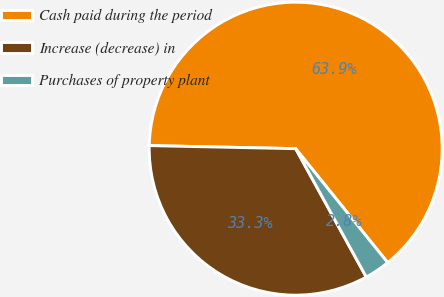<chart> <loc_0><loc_0><loc_500><loc_500><pie_chart><fcel>Cash paid during the period<fcel>Increase (decrease) in<fcel>Purchases of property plant<nl><fcel>63.85%<fcel>33.33%<fcel>2.81%<nl></chart> 